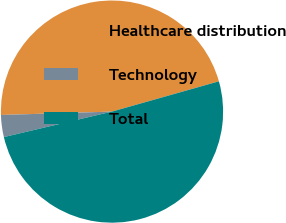Convert chart to OTSL. <chart><loc_0><loc_0><loc_500><loc_500><pie_chart><fcel>Healthcare distribution<fcel>Technology<fcel>Total<nl><fcel>46.1%<fcel>3.2%<fcel>50.71%<nl></chart> 